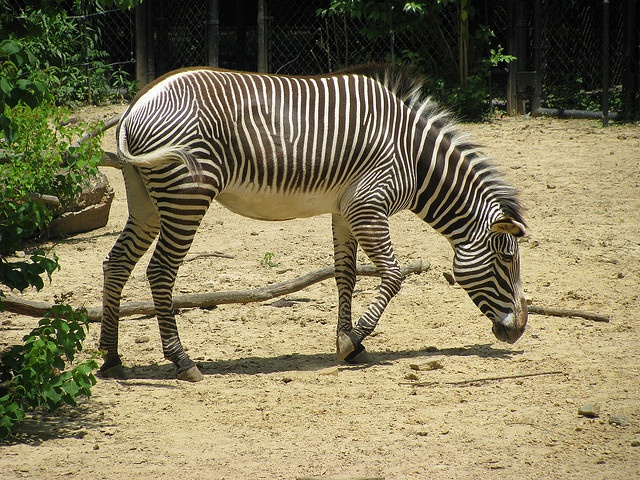Describe the objects in this image and their specific colors. I can see a zebra in darkgreen, black, olive, gray, and ivory tones in this image. 